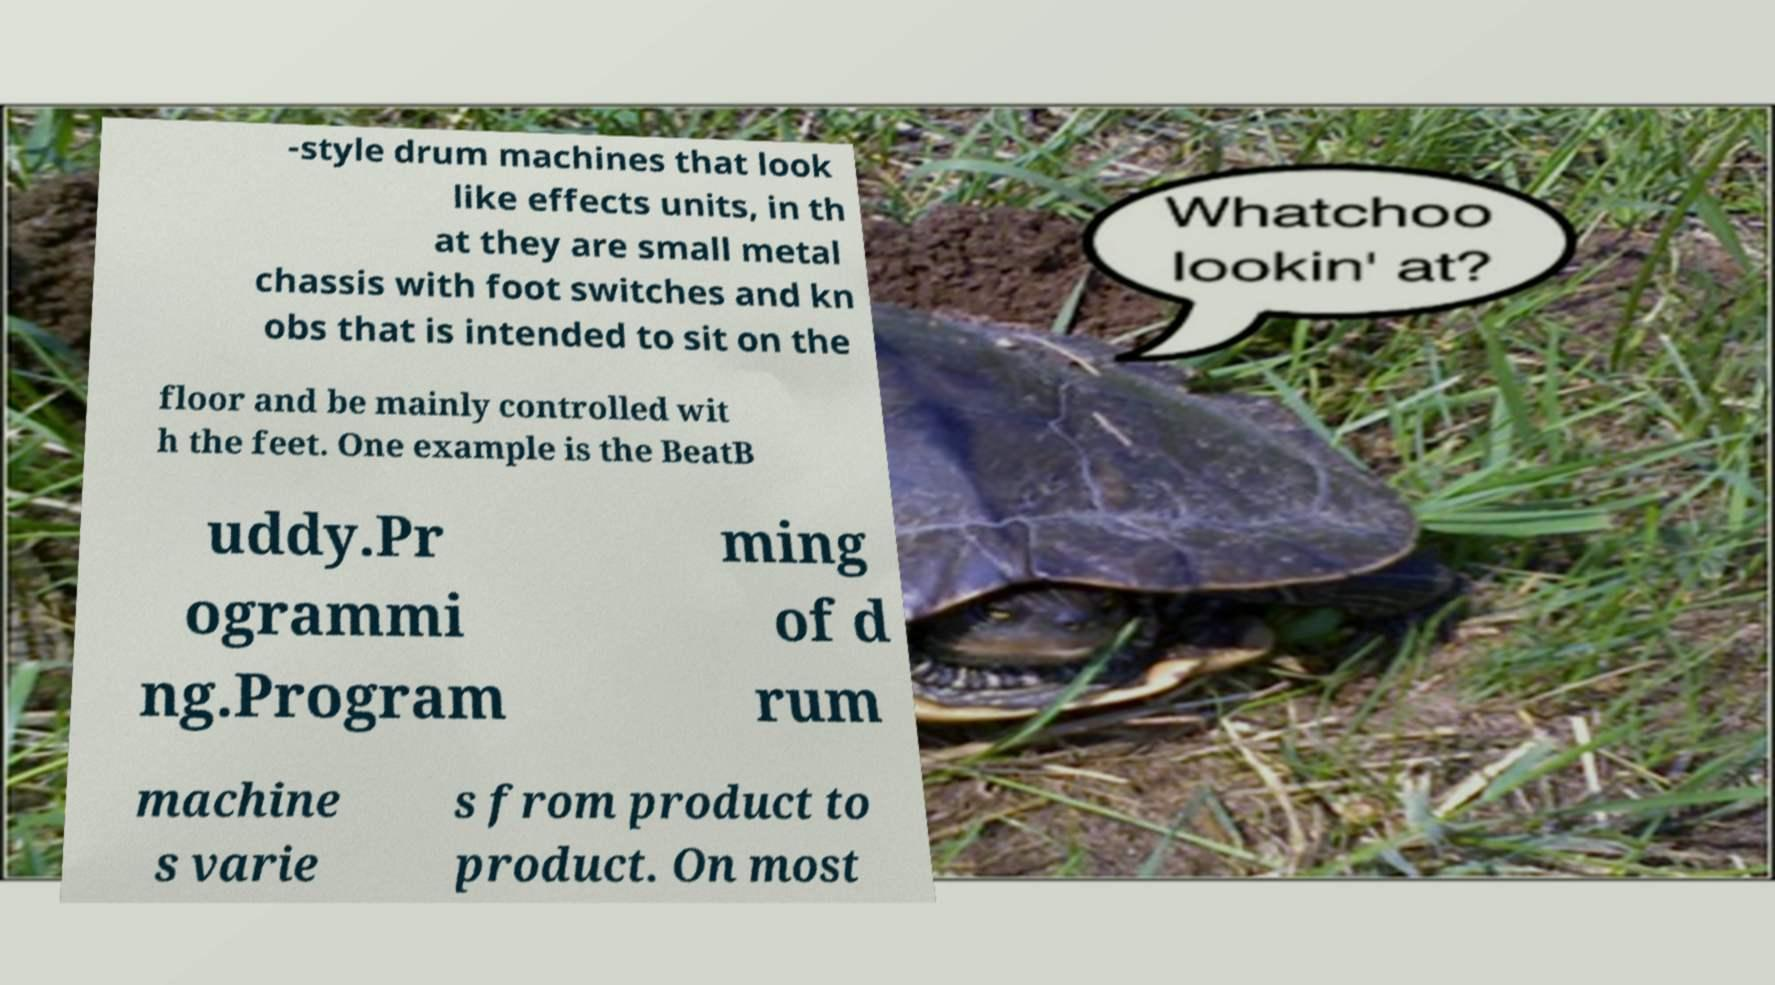Could you extract and type out the text from this image? -style drum machines that look like effects units, in th at they are small metal chassis with foot switches and kn obs that is intended to sit on the floor and be mainly controlled wit h the feet. One example is the BeatB uddy.Pr ogrammi ng.Program ming of d rum machine s varie s from product to product. On most 